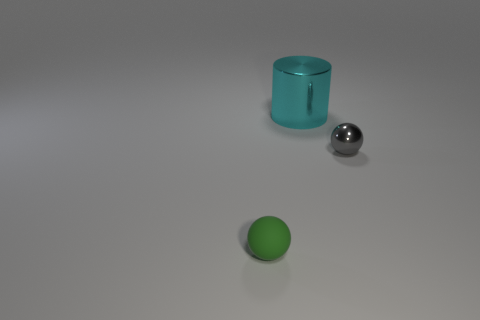Describe the lighting and shadows in the image. The lighting in the image appears to be coming from above, as indicated by the soft shadows cast directly underneath the objects. The shadows are slightly elongated, suggesting the light source is not directly overhead but at a slight angle. The smoothness of the shadows shows that the light is diffused, providing an even illumination over the scene. 